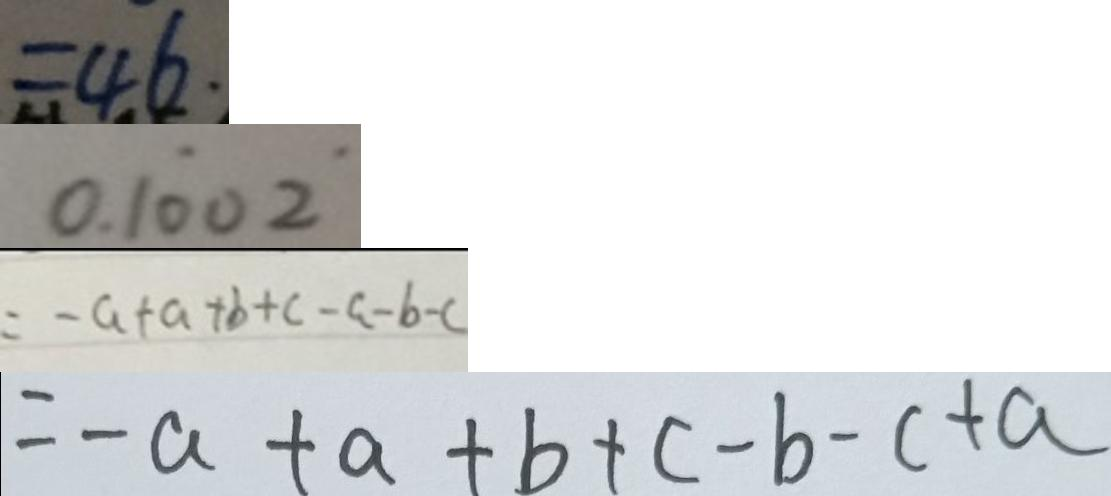<formula> <loc_0><loc_0><loc_500><loc_500>= 4 6 . 
 0 . 1 \dot { 0 } 0 \dot { 2 } 
 = - a + a + b + c - a - b - c 
 = - a + a + b + c - b - c + a</formula> 